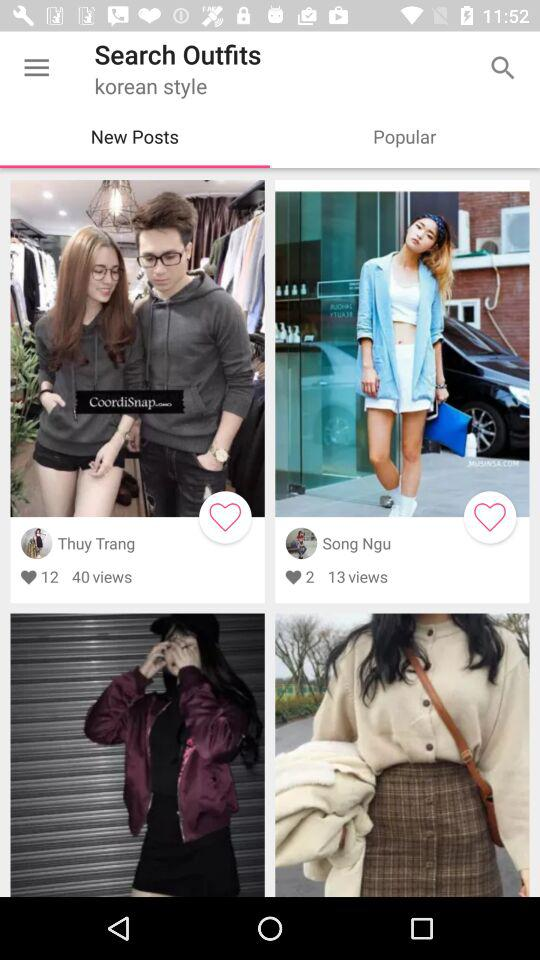How many total views did the post "Song Ngu" get? The total view is 13. 